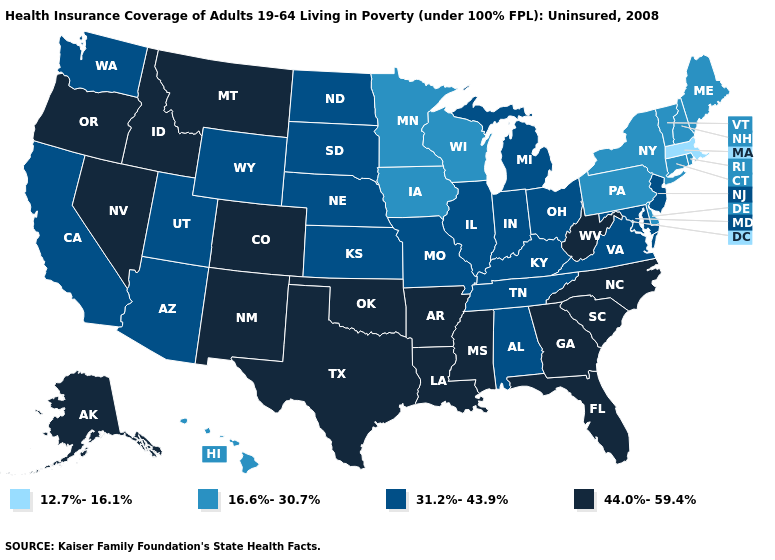Name the states that have a value in the range 44.0%-59.4%?
Answer briefly. Alaska, Arkansas, Colorado, Florida, Georgia, Idaho, Louisiana, Mississippi, Montana, Nevada, New Mexico, North Carolina, Oklahoma, Oregon, South Carolina, Texas, West Virginia. Name the states that have a value in the range 16.6%-30.7%?
Keep it brief. Connecticut, Delaware, Hawaii, Iowa, Maine, Minnesota, New Hampshire, New York, Pennsylvania, Rhode Island, Vermont, Wisconsin. Does Texas have the highest value in the USA?
Keep it brief. Yes. Does the map have missing data?
Quick response, please. No. Name the states that have a value in the range 12.7%-16.1%?
Short answer required. Massachusetts. Name the states that have a value in the range 44.0%-59.4%?
Give a very brief answer. Alaska, Arkansas, Colorado, Florida, Georgia, Idaho, Louisiana, Mississippi, Montana, Nevada, New Mexico, North Carolina, Oklahoma, Oregon, South Carolina, Texas, West Virginia. Name the states that have a value in the range 44.0%-59.4%?
Write a very short answer. Alaska, Arkansas, Colorado, Florida, Georgia, Idaho, Louisiana, Mississippi, Montana, Nevada, New Mexico, North Carolina, Oklahoma, Oregon, South Carolina, Texas, West Virginia. What is the value of Indiana?
Keep it brief. 31.2%-43.9%. What is the value of North Dakota?
Keep it brief. 31.2%-43.9%. What is the highest value in the USA?
Be succinct. 44.0%-59.4%. Does Virginia have the highest value in the South?
Be succinct. No. What is the highest value in the USA?
Answer briefly. 44.0%-59.4%. Which states have the lowest value in the USA?
Keep it brief. Massachusetts. Name the states that have a value in the range 31.2%-43.9%?
Short answer required. Alabama, Arizona, California, Illinois, Indiana, Kansas, Kentucky, Maryland, Michigan, Missouri, Nebraska, New Jersey, North Dakota, Ohio, South Dakota, Tennessee, Utah, Virginia, Washington, Wyoming. How many symbols are there in the legend?
Keep it brief. 4. 